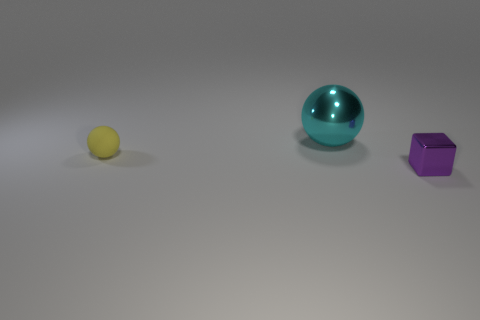Do the shiny object to the left of the purple object and the yellow thing have the same size?
Your response must be concise. No. How many shiny things are either balls or tiny purple objects?
Your answer should be compact. 2. What number of cubes are on the left side of the tiny object that is behind the small purple metal object?
Offer a terse response. 0. What is the shape of the object that is on the left side of the tiny purple metallic block and right of the yellow thing?
Your answer should be very brief. Sphere. There is a object that is in front of the small thing that is behind the tiny thing that is right of the yellow matte sphere; what is its material?
Your answer should be compact. Metal. What is the material of the large cyan thing?
Give a very brief answer. Metal. Does the small purple block have the same material as the tiny thing behind the small purple object?
Your answer should be compact. No. What color is the sphere that is to the left of the shiny thing that is behind the tiny metal object?
Offer a very short reply. Yellow. There is a object that is in front of the metallic ball and left of the small purple thing; what size is it?
Give a very brief answer. Small. How many other things are there of the same shape as the small metallic object?
Your answer should be very brief. 0. 